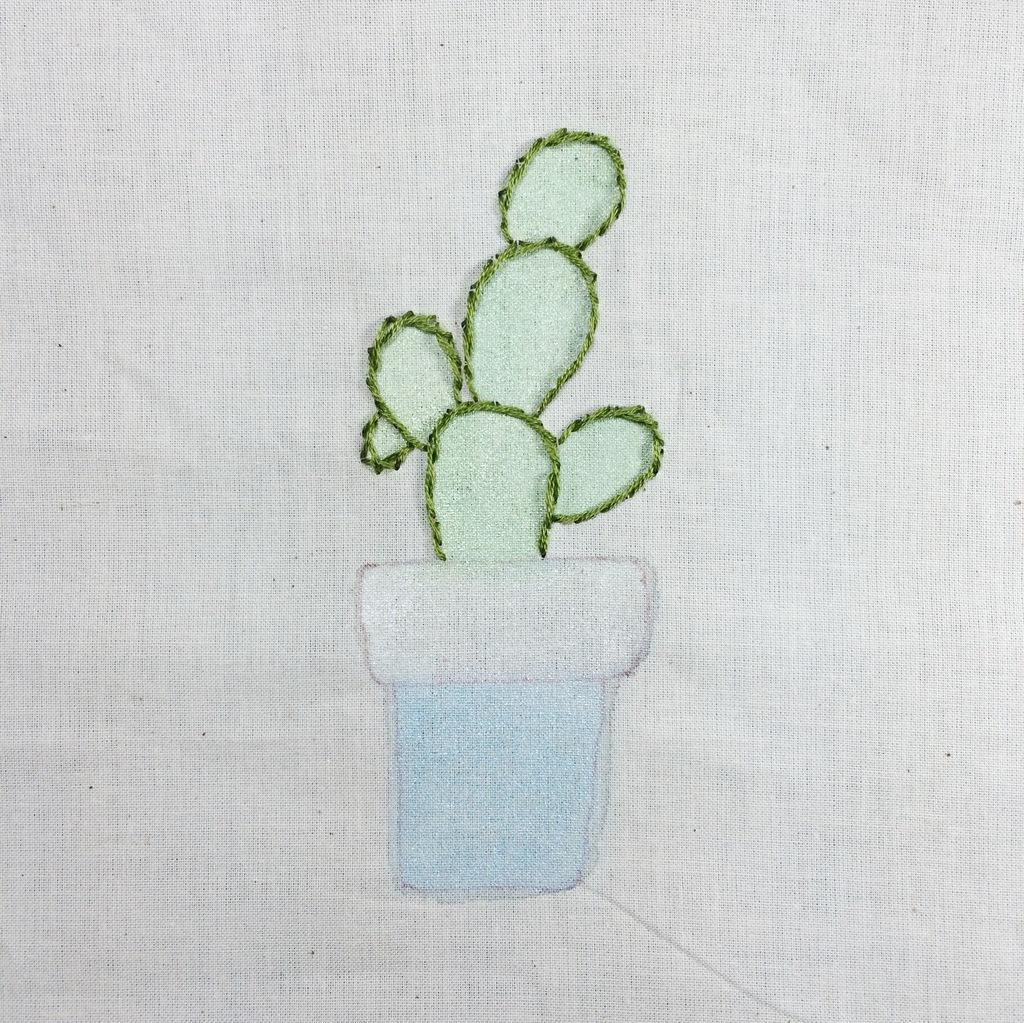Can you describe this image briefly? In this picture we can see one diagram of a plant along with a pot on the cloth. 